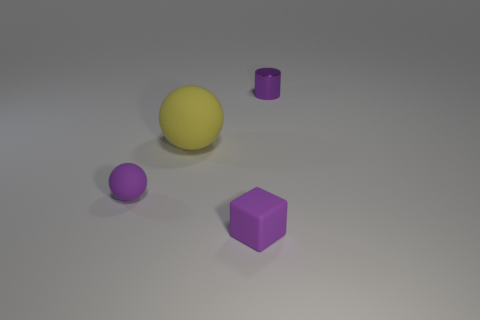Is the color of the shiny cylinder the same as the block?
Keep it short and to the point. Yes. There is a tiny metal object that is the same color as the tiny matte block; what is its shape?
Keep it short and to the point. Cylinder. There is a small object that is both to the right of the large yellow thing and in front of the yellow sphere; what is its material?
Your answer should be compact. Rubber. Does the small object right of the matte cube have the same color as the small thing that is left of the yellow ball?
Offer a very short reply. Yes. Is the small object left of the big yellow sphere made of the same material as the small cylinder?
Your answer should be very brief. No. What is the color of the other rubber object that is the same shape as the big thing?
Your answer should be very brief. Purple. Is there any other thing that has the same shape as the tiny shiny object?
Your answer should be compact. No. Are there the same number of small objects that are behind the tiny shiny cylinder and rubber objects?
Ensure brevity in your answer.  No. Are there any tiny purple rubber objects on the right side of the tiny purple cube?
Keep it short and to the point. No. There is a purple matte object left of the tiny purple rubber thing right of the purple rubber object that is to the left of the purple rubber block; what is its size?
Give a very brief answer. Small. 